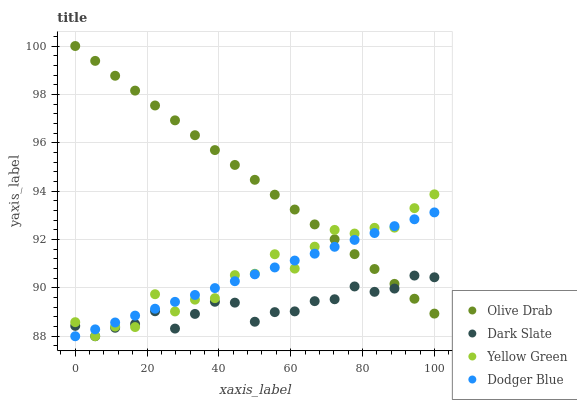Does Dark Slate have the minimum area under the curve?
Answer yes or no. Yes. Does Olive Drab have the maximum area under the curve?
Answer yes or no. Yes. Does Dodger Blue have the minimum area under the curve?
Answer yes or no. No. Does Dodger Blue have the maximum area under the curve?
Answer yes or no. No. Is Dodger Blue the smoothest?
Answer yes or no. Yes. Is Yellow Green the roughest?
Answer yes or no. Yes. Is Yellow Green the smoothest?
Answer yes or no. No. Is Dodger Blue the roughest?
Answer yes or no. No. Does Dark Slate have the lowest value?
Answer yes or no. Yes. Does Yellow Green have the lowest value?
Answer yes or no. No. Does Olive Drab have the highest value?
Answer yes or no. Yes. Does Dodger Blue have the highest value?
Answer yes or no. No. Does Dodger Blue intersect Dark Slate?
Answer yes or no. Yes. Is Dodger Blue less than Dark Slate?
Answer yes or no. No. Is Dodger Blue greater than Dark Slate?
Answer yes or no. No. 